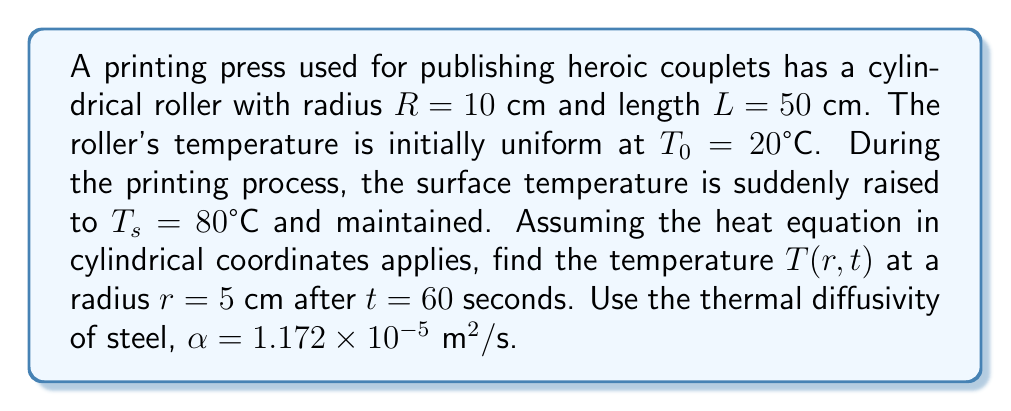Teach me how to tackle this problem. 1) The heat equation in cylindrical coordinates for this scenario is:

   $$\frac{\partial T}{\partial t} = \alpha \left(\frac{\partial^2 T}{\partial r^2} + \frac{1}{r}\frac{\partial T}{\partial r}\right)$$

2) The boundary conditions are:
   $T(R,t) = T_s = 80°C$ for $t > 0$
   $T(r,0) = T_0 = 20°C$ for $0 \leq r < R$

3) The solution to this equation with these conditions is:

   $$T(r,t) = T_s + (T_0 - T_s) \sum_{n=1}^{\infty} \frac{2J_0(r\alpha_n)}{RJ_1(R\alpha_n)\alpha_n}e^{-\alpha\alpha_n^2t}$$

   where $J_0$ and $J_1$ are Bessel functions of the first kind, and $\alpha_n$ are the positive roots of $J_0(R\alpha_n) = 0$.

4) We need to calculate the first few terms of this series. Let's use the first three roots:
   $\alpha_1 \approx 2.4048/R$, $\alpha_2 \approx 5.5201/R$, $\alpha_3 \approx 8.6537/R$

5) Substituting the given values:
   $r = 0.05$ m, $R = 0.1$ m, $t = 60$ s, $\alpha = 1.172 \times 10^{-5} \text{ m}^2/\text{s}$
   $T_s = 80°C$, $T_0 = 20°C$

6) Calculating the first three terms:

   Term 1: $\approx 41.8795 \times e^{-0.4062} \approx 27.7151$
   Term 2: $\approx -5.5201 \times e^{-2.1403} \approx -0.6451$
   Term 3: $\approx 2.5082 \times e^{-5.2561} \approx 0.0129$

7) Summing up:
   $T(0.05, 60) \approx 80 + (20 - 80)(27.7151 - 0.6451 + 0.0129) \approx 53.14°C$
Answer: $53.14°C$ 